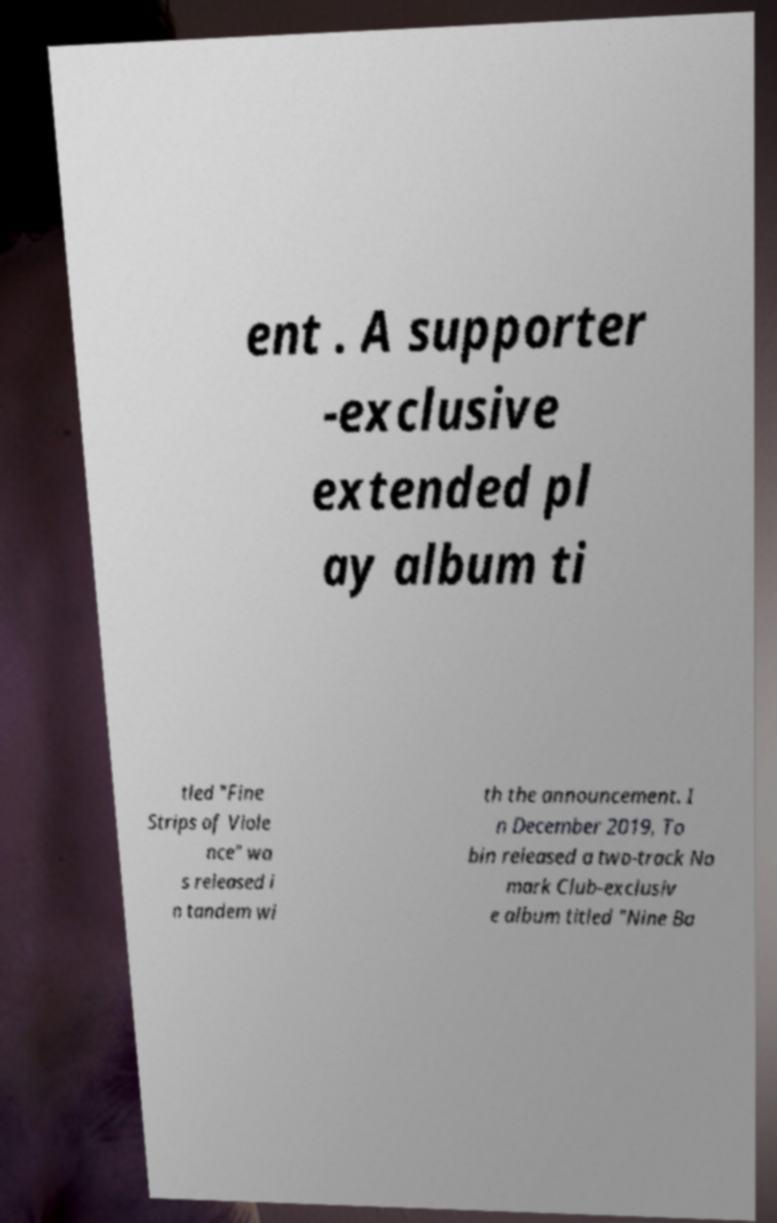Could you extract and type out the text from this image? ent . A supporter -exclusive extended pl ay album ti tled "Fine Strips of Viole nce" wa s released i n tandem wi th the announcement. I n December 2019, To bin released a two-track No mark Club-exclusiv e album titled "Nine Ba 